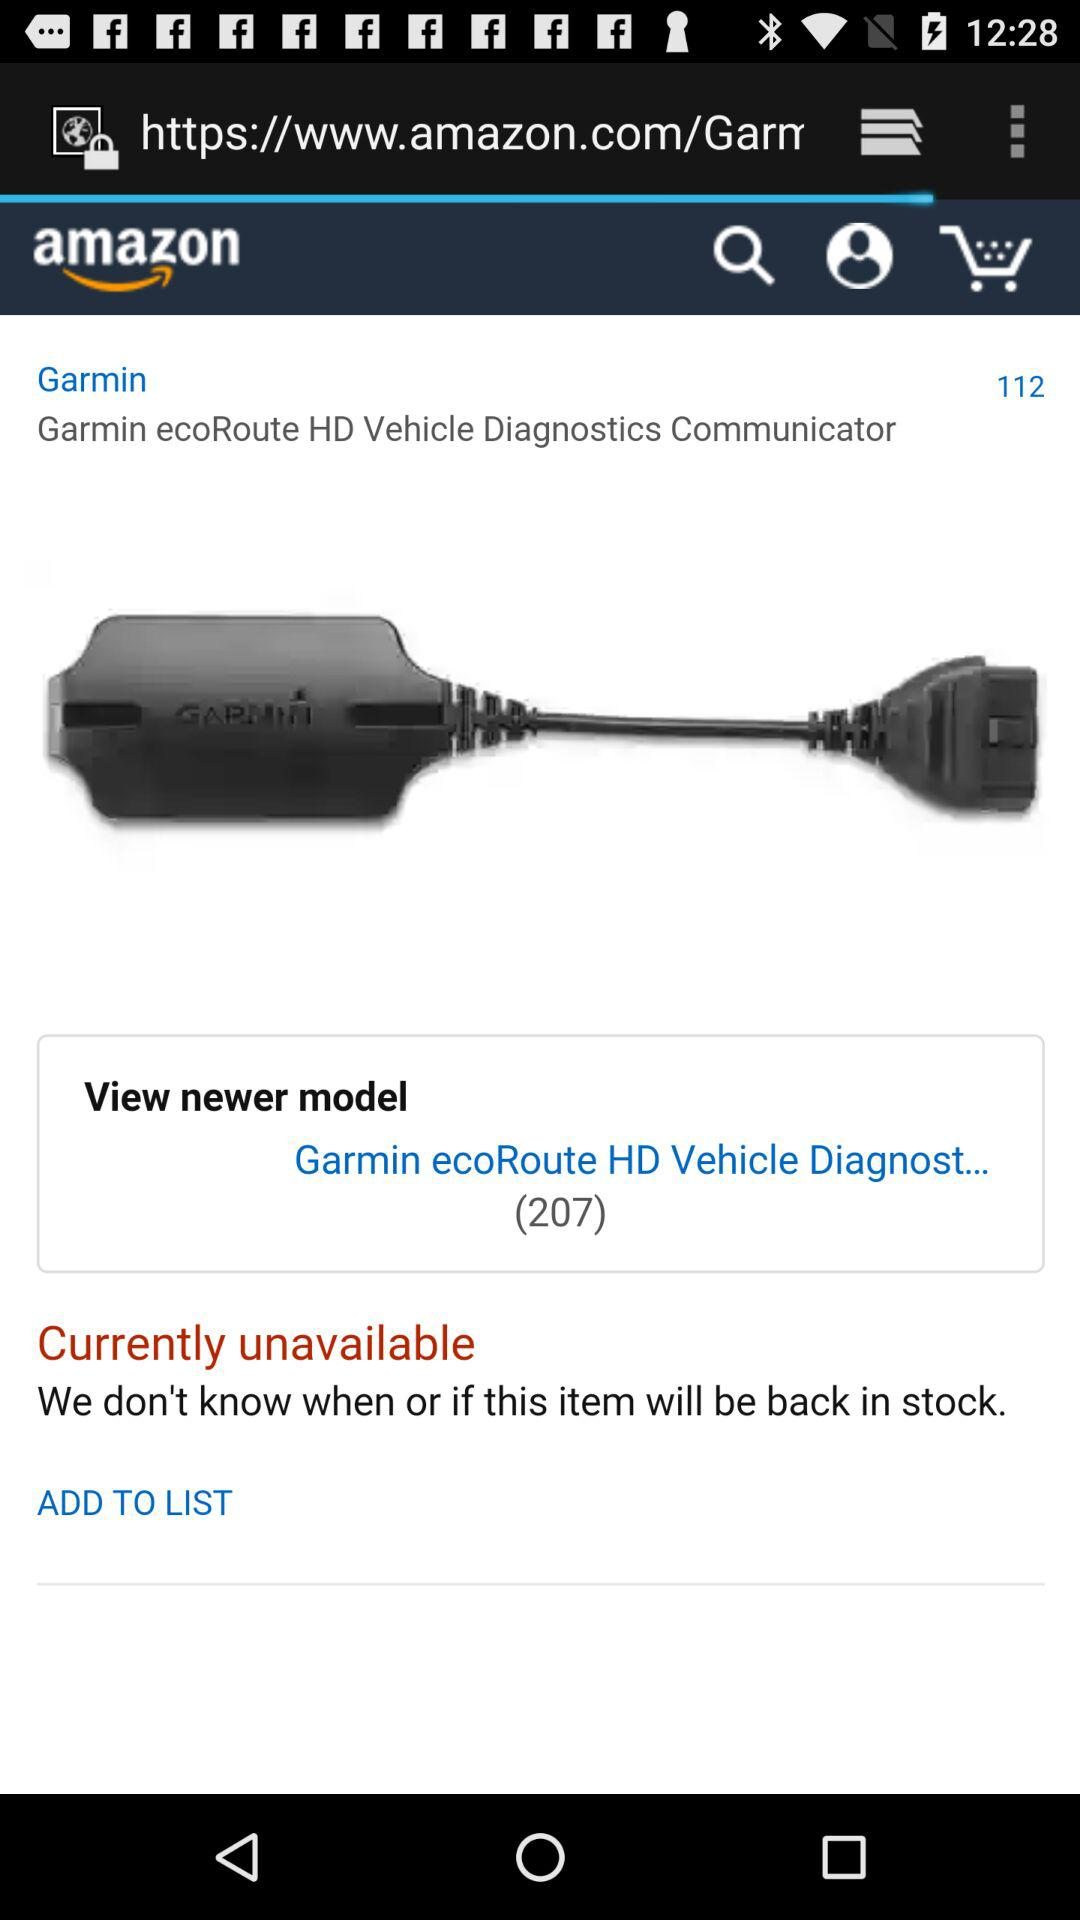How much is the "Garmin" product?
When the provided information is insufficient, respond with <no answer>. <no answer> 